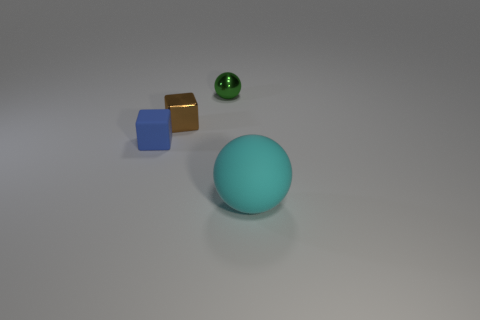Add 4 tiny green balls. How many objects exist? 8 Add 1 large things. How many large things are left? 2 Add 2 yellow balls. How many yellow balls exist? 2 Subtract 0 purple cubes. How many objects are left? 4 Subtract all tiny gray metallic blocks. Subtract all blue things. How many objects are left? 3 